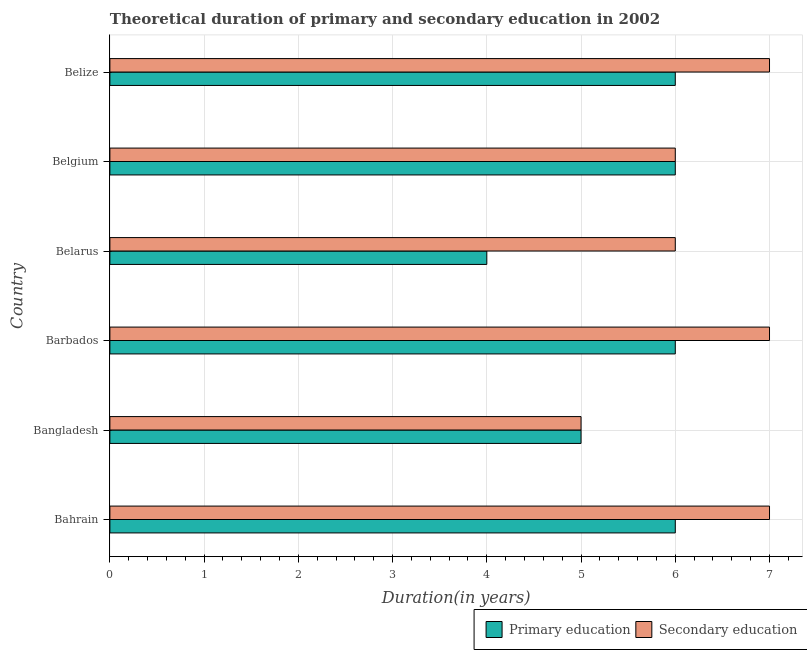What is the label of the 4th group of bars from the top?
Provide a short and direct response. Barbados. In how many cases, is the number of bars for a given country not equal to the number of legend labels?
Offer a very short reply. 0. What is the duration of primary education in Belgium?
Offer a terse response. 6. Across all countries, what is the minimum duration of primary education?
Provide a succinct answer. 4. In which country was the duration of primary education maximum?
Give a very brief answer. Bahrain. In which country was the duration of primary education minimum?
Offer a very short reply. Belarus. What is the total duration of primary education in the graph?
Your answer should be compact. 33. What is the difference between the duration of secondary education in Bangladesh and that in Belgium?
Offer a very short reply. -1. What is the difference between the duration of primary education in Belize and the duration of secondary education in Belarus?
Give a very brief answer. 0. What is the average duration of primary education per country?
Offer a terse response. 5.5. What is the difference between the duration of secondary education and duration of primary education in Belgium?
Ensure brevity in your answer.  0. What is the ratio of the duration of secondary education in Bahrain to that in Belgium?
Provide a short and direct response. 1.17. Is the duration of primary education in Bahrain less than that in Bangladesh?
Your response must be concise. No. Is the difference between the duration of secondary education in Belarus and Belize greater than the difference between the duration of primary education in Belarus and Belize?
Offer a terse response. Yes. What is the difference between the highest and the lowest duration of secondary education?
Your response must be concise. 2. In how many countries, is the duration of secondary education greater than the average duration of secondary education taken over all countries?
Ensure brevity in your answer.  3. What does the 1st bar from the top in Belgium represents?
Your answer should be very brief. Secondary education. What does the 2nd bar from the bottom in Belgium represents?
Your answer should be very brief. Secondary education. Are all the bars in the graph horizontal?
Keep it short and to the point. Yes. How many countries are there in the graph?
Offer a terse response. 6. Does the graph contain any zero values?
Provide a short and direct response. No. Does the graph contain grids?
Provide a succinct answer. Yes. How many legend labels are there?
Ensure brevity in your answer.  2. What is the title of the graph?
Provide a short and direct response. Theoretical duration of primary and secondary education in 2002. Does "Urban agglomerations" appear as one of the legend labels in the graph?
Give a very brief answer. No. What is the label or title of the X-axis?
Offer a terse response. Duration(in years). What is the label or title of the Y-axis?
Make the answer very short. Country. What is the Duration(in years) in Primary education in Bahrain?
Give a very brief answer. 6. What is the Duration(in years) of Primary education in Bangladesh?
Provide a short and direct response. 5. What is the Duration(in years) of Secondary education in Bangladesh?
Give a very brief answer. 5. What is the Duration(in years) of Secondary education in Belarus?
Your answer should be very brief. 6. What is the Duration(in years) in Secondary education in Belgium?
Ensure brevity in your answer.  6. What is the Duration(in years) of Primary education in Belize?
Give a very brief answer. 6. What is the Duration(in years) in Secondary education in Belize?
Give a very brief answer. 7. Across all countries, what is the maximum Duration(in years) of Primary education?
Offer a very short reply. 6. Across all countries, what is the minimum Duration(in years) of Primary education?
Give a very brief answer. 4. Across all countries, what is the minimum Duration(in years) in Secondary education?
Your response must be concise. 5. What is the difference between the Duration(in years) of Primary education in Bahrain and that in Bangladesh?
Offer a very short reply. 1. What is the difference between the Duration(in years) in Secondary education in Bahrain and that in Bangladesh?
Make the answer very short. 2. What is the difference between the Duration(in years) in Primary education in Bahrain and that in Barbados?
Offer a very short reply. 0. What is the difference between the Duration(in years) in Primary education in Bahrain and that in Belarus?
Keep it short and to the point. 2. What is the difference between the Duration(in years) in Primary education in Bahrain and that in Belgium?
Offer a very short reply. 0. What is the difference between the Duration(in years) in Secondary education in Bahrain and that in Belgium?
Provide a succinct answer. 1. What is the difference between the Duration(in years) of Secondary education in Bahrain and that in Belize?
Provide a short and direct response. 0. What is the difference between the Duration(in years) of Primary education in Bangladesh and that in Barbados?
Make the answer very short. -1. What is the difference between the Duration(in years) in Secondary education in Bangladesh and that in Barbados?
Make the answer very short. -2. What is the difference between the Duration(in years) in Primary education in Bangladesh and that in Belarus?
Your response must be concise. 1. What is the difference between the Duration(in years) of Secondary education in Bangladesh and that in Belarus?
Your response must be concise. -1. What is the difference between the Duration(in years) in Primary education in Bangladesh and that in Belize?
Offer a very short reply. -1. What is the difference between the Duration(in years) in Secondary education in Barbados and that in Belarus?
Your answer should be compact. 1. What is the difference between the Duration(in years) of Primary education in Barbados and that in Belgium?
Make the answer very short. 0. What is the difference between the Duration(in years) in Secondary education in Barbados and that in Belgium?
Keep it short and to the point. 1. What is the difference between the Duration(in years) of Secondary education in Belarus and that in Belgium?
Your response must be concise. 0. What is the difference between the Duration(in years) in Primary education in Belarus and that in Belize?
Make the answer very short. -2. What is the difference between the Duration(in years) in Secondary education in Belarus and that in Belize?
Give a very brief answer. -1. What is the difference between the Duration(in years) in Primary education in Belgium and that in Belize?
Your response must be concise. 0. What is the difference between the Duration(in years) in Primary education in Bahrain and the Duration(in years) in Secondary education in Belarus?
Offer a terse response. 0. What is the difference between the Duration(in years) of Primary education in Bahrain and the Duration(in years) of Secondary education in Belgium?
Give a very brief answer. 0. What is the difference between the Duration(in years) in Primary education in Bangladesh and the Duration(in years) in Secondary education in Belarus?
Offer a terse response. -1. What is the difference between the Duration(in years) of Primary education in Bangladesh and the Duration(in years) of Secondary education in Belgium?
Make the answer very short. -1. What is the difference between the Duration(in years) in Primary education in Bangladesh and the Duration(in years) in Secondary education in Belize?
Provide a short and direct response. -2. What is the difference between the Duration(in years) of Primary education in Barbados and the Duration(in years) of Secondary education in Belarus?
Provide a short and direct response. 0. What is the difference between the Duration(in years) of Primary education in Barbados and the Duration(in years) of Secondary education in Belgium?
Offer a terse response. 0. What is the average Duration(in years) in Primary education per country?
Make the answer very short. 5.5. What is the average Duration(in years) in Secondary education per country?
Make the answer very short. 6.33. What is the difference between the Duration(in years) in Primary education and Duration(in years) in Secondary education in Bahrain?
Your answer should be very brief. -1. What is the difference between the Duration(in years) in Primary education and Duration(in years) in Secondary education in Bangladesh?
Provide a succinct answer. 0. What is the difference between the Duration(in years) of Primary education and Duration(in years) of Secondary education in Barbados?
Provide a short and direct response. -1. What is the difference between the Duration(in years) in Primary education and Duration(in years) in Secondary education in Belarus?
Offer a terse response. -2. What is the difference between the Duration(in years) in Primary education and Duration(in years) in Secondary education in Belize?
Give a very brief answer. -1. What is the ratio of the Duration(in years) of Primary education in Bahrain to that in Bangladesh?
Make the answer very short. 1.2. What is the ratio of the Duration(in years) of Secondary education in Bahrain to that in Bangladesh?
Your response must be concise. 1.4. What is the ratio of the Duration(in years) of Primary education in Bahrain to that in Barbados?
Your response must be concise. 1. What is the ratio of the Duration(in years) in Secondary education in Bahrain to that in Barbados?
Keep it short and to the point. 1. What is the ratio of the Duration(in years) of Primary education in Bahrain to that in Belarus?
Your answer should be compact. 1.5. What is the ratio of the Duration(in years) of Primary education in Bahrain to that in Belize?
Provide a succinct answer. 1. What is the ratio of the Duration(in years) in Secondary education in Bahrain to that in Belize?
Ensure brevity in your answer.  1. What is the ratio of the Duration(in years) in Secondary education in Bangladesh to that in Belarus?
Offer a terse response. 0.83. What is the ratio of the Duration(in years) in Primary education in Barbados to that in Belarus?
Ensure brevity in your answer.  1.5. What is the ratio of the Duration(in years) of Primary education in Barbados to that in Belize?
Your answer should be very brief. 1. What is the ratio of the Duration(in years) of Primary education in Belarus to that in Belgium?
Your answer should be compact. 0.67. What is the ratio of the Duration(in years) in Secondary education in Belarus to that in Belgium?
Provide a short and direct response. 1. What is the ratio of the Duration(in years) in Secondary education in Belgium to that in Belize?
Give a very brief answer. 0.86. What is the difference between the highest and the lowest Duration(in years) of Primary education?
Offer a very short reply. 2. 